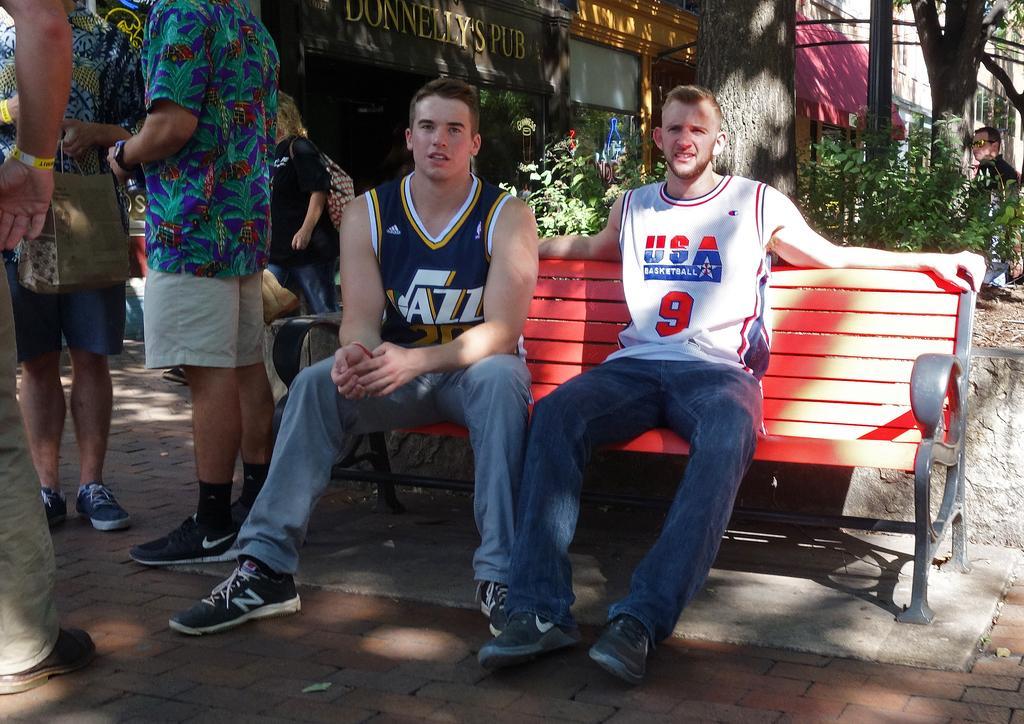How would you summarize this image in a sentence or two? In this image I can see people where two of them are sitting on a red colour bench and rest all are standing. In the background I can see few plants, trees, buildings and here I can see something is written. 